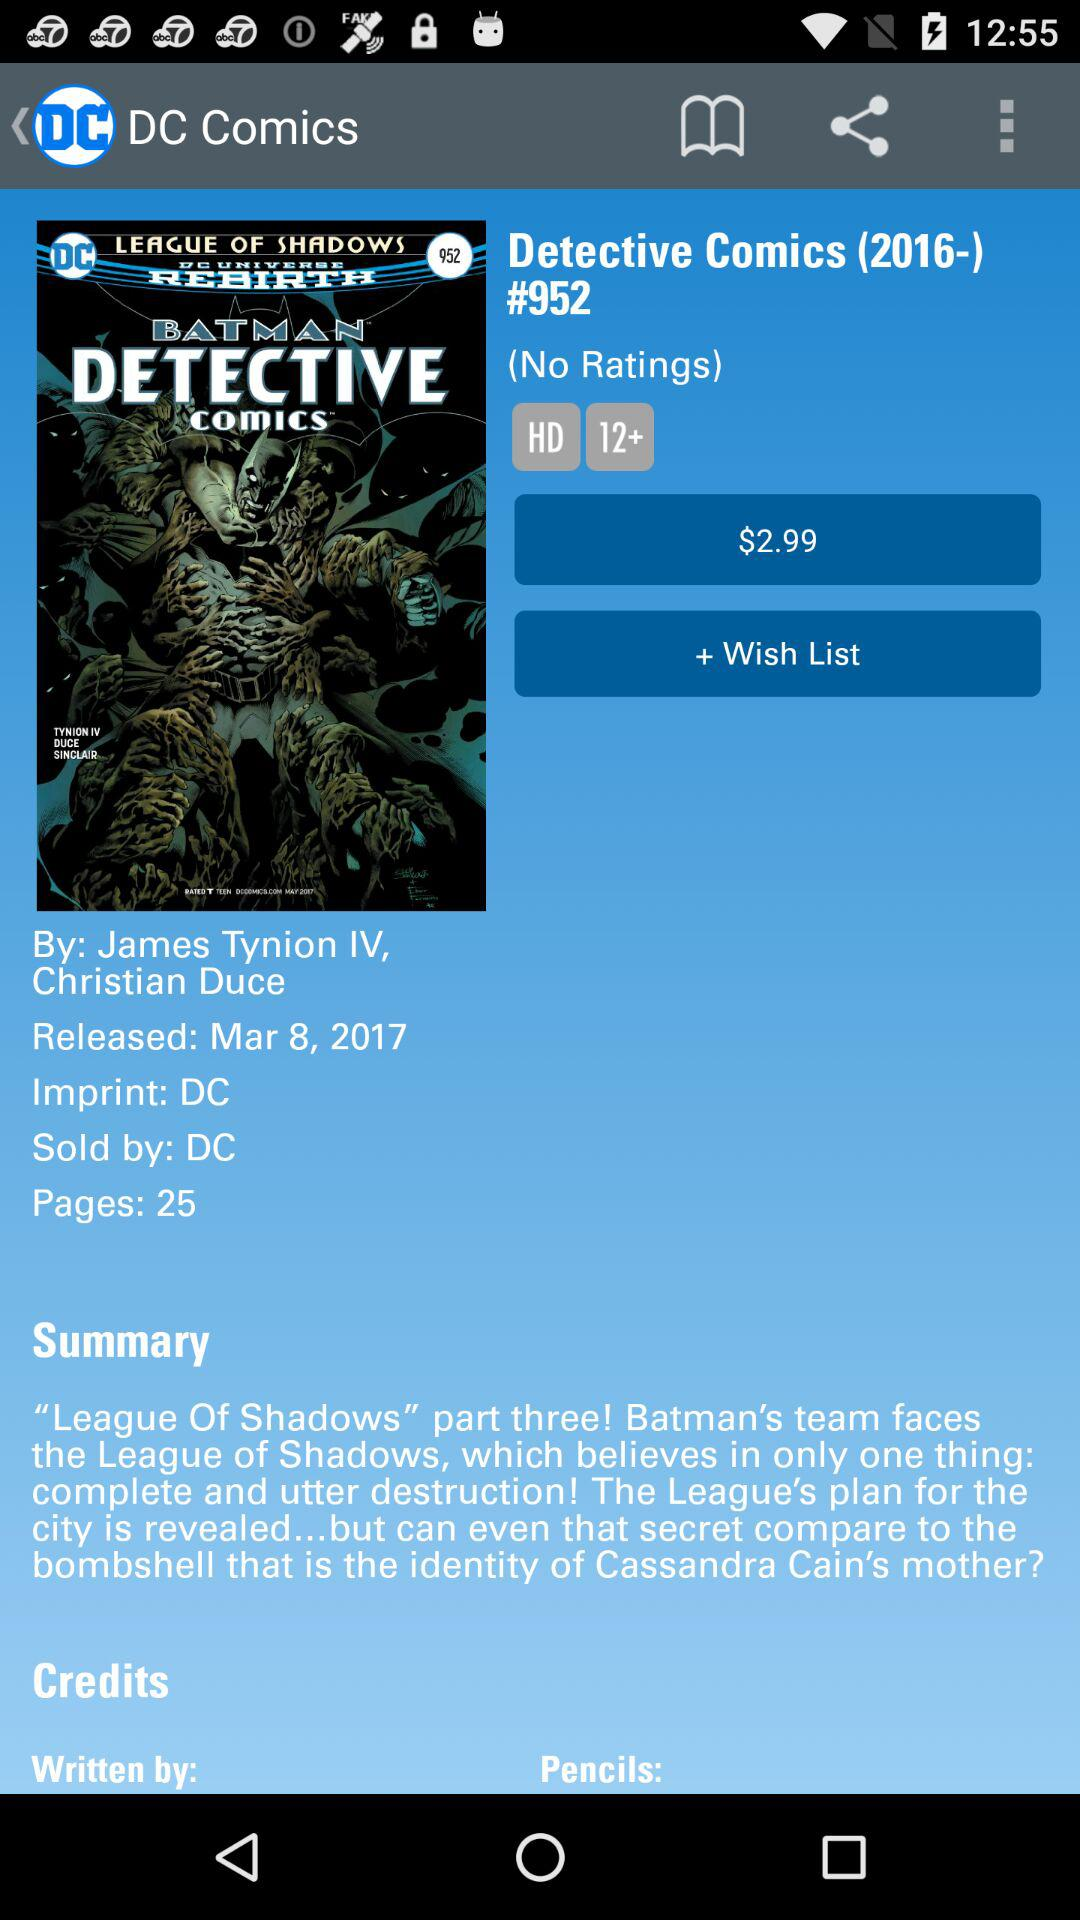By whom is "Detective Comics" sold? "Detective Comics" is sold by "DC". 